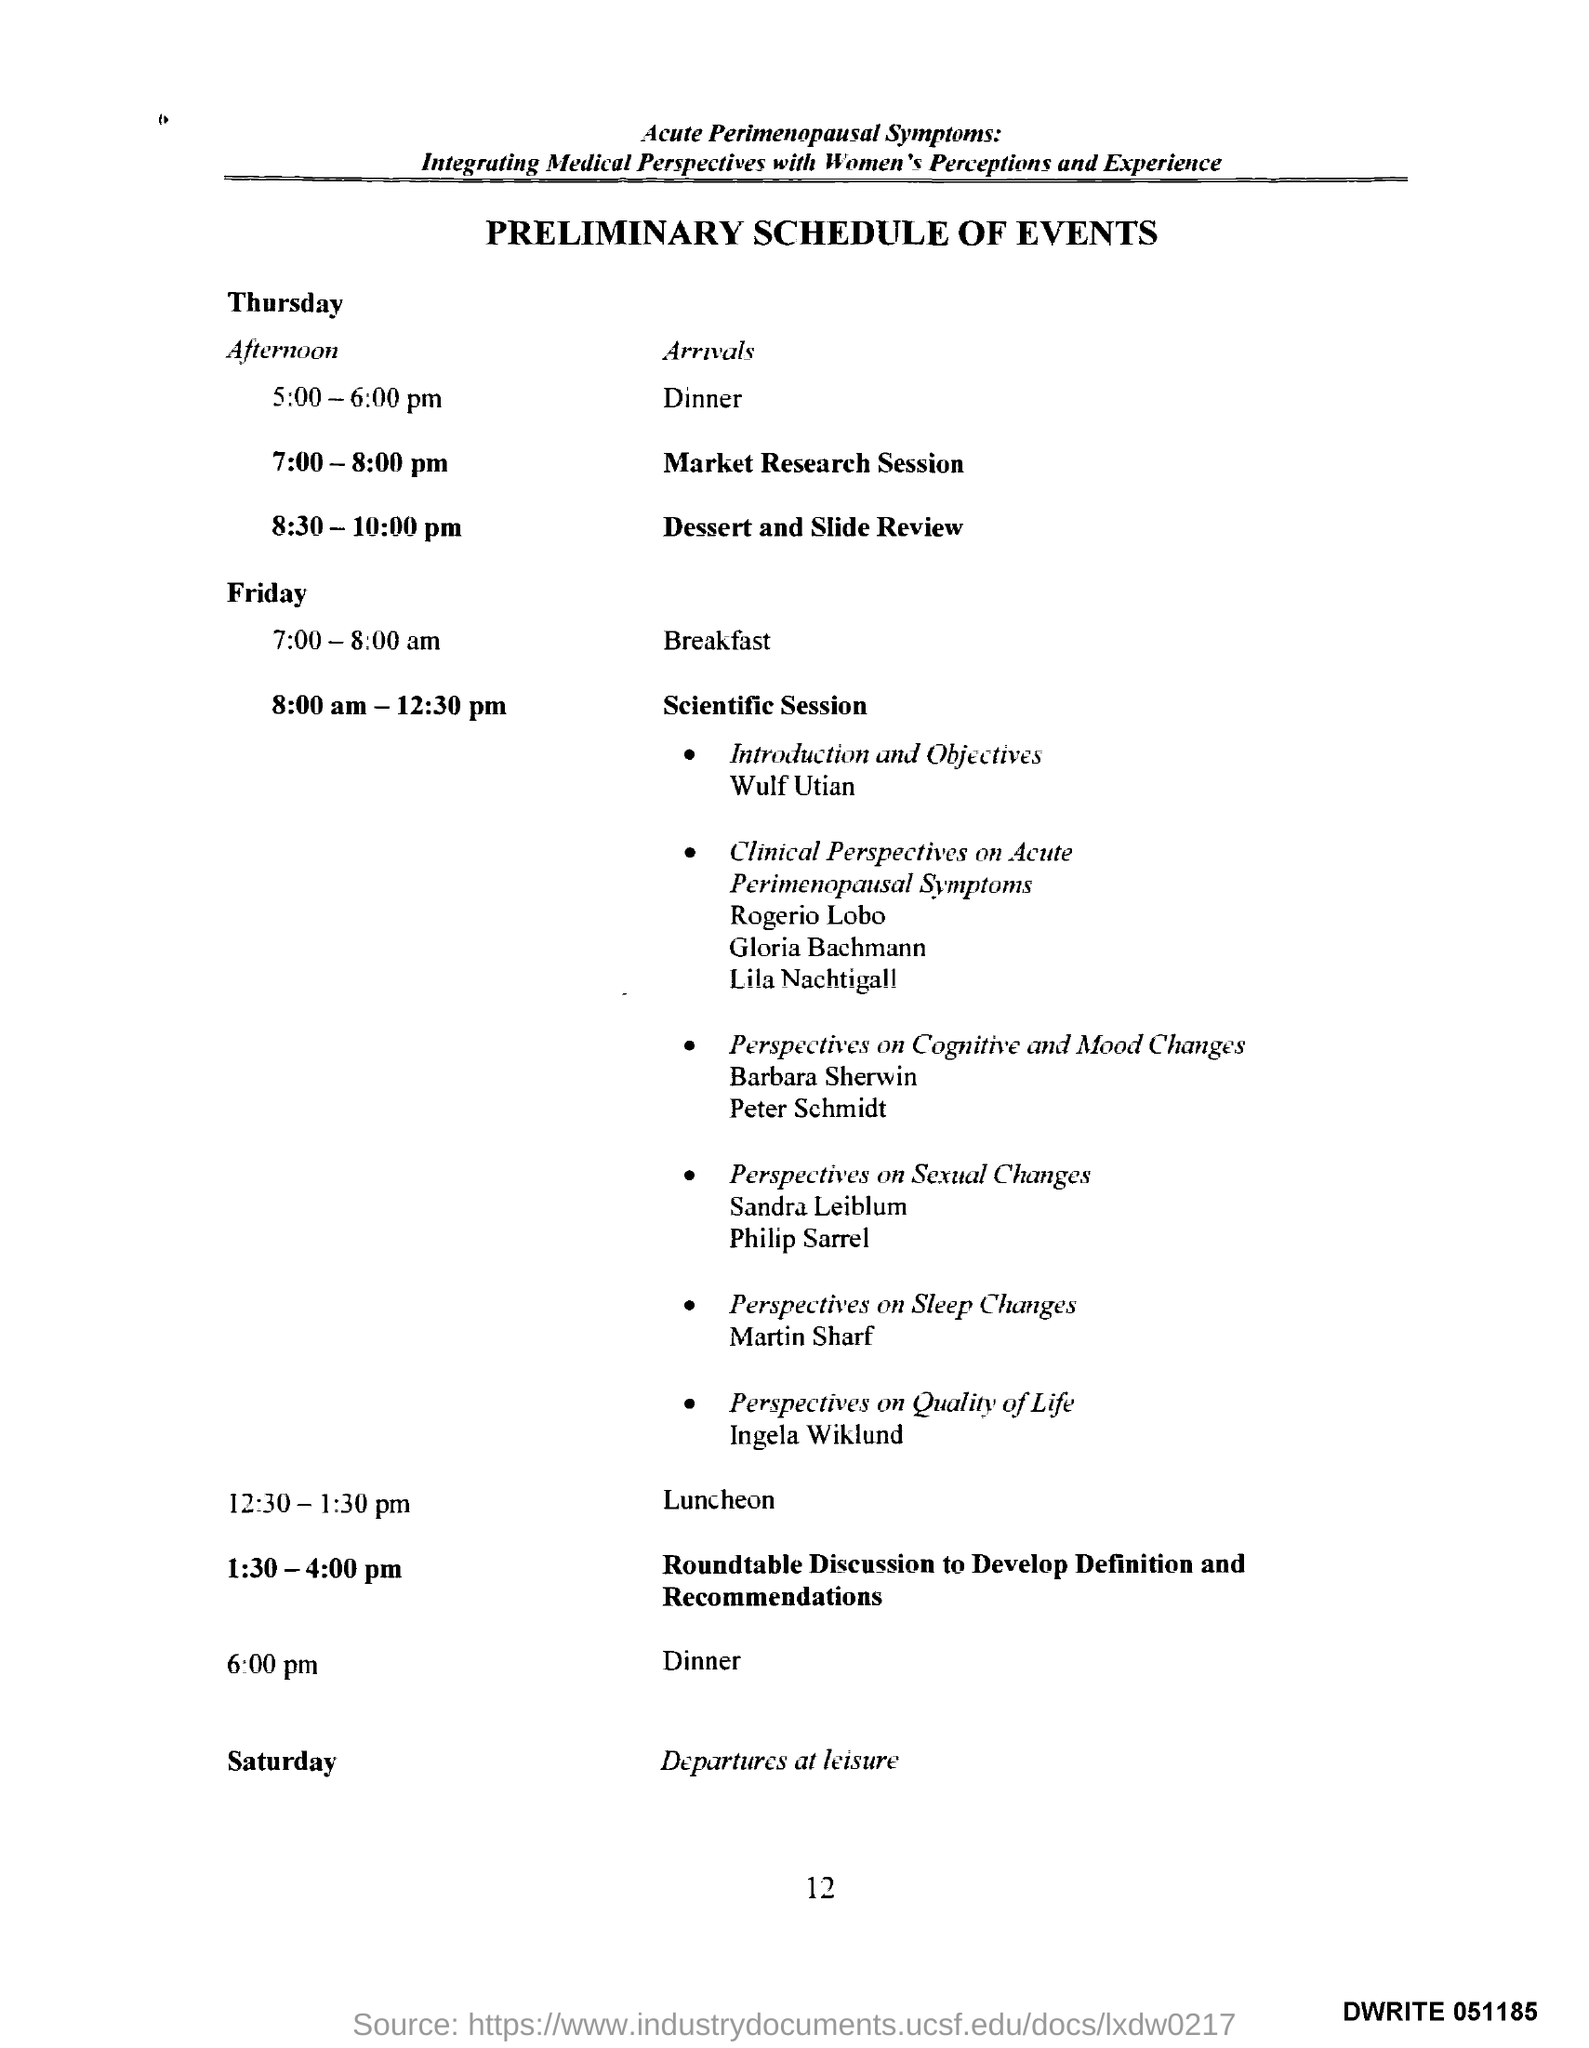Draw attention to some important aspects in this diagram. The scientific session scheduled for Friday from 8:00 am to 12:30 pm is scheduled for Friday 8:00 am-12:30 pm. The preliminary schedule of events is the heading of the document. Saturday is the day when the departure activities are scheduled. 